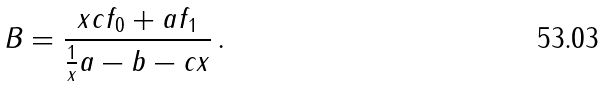Convert formula to latex. <formula><loc_0><loc_0><loc_500><loc_500>B = \frac { x c f _ { 0 } + a f _ { 1 } } { \frac { 1 } { x } a - b - c x } \, .</formula> 